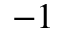<formula> <loc_0><loc_0><loc_500><loc_500>^ { - 1 }</formula> 